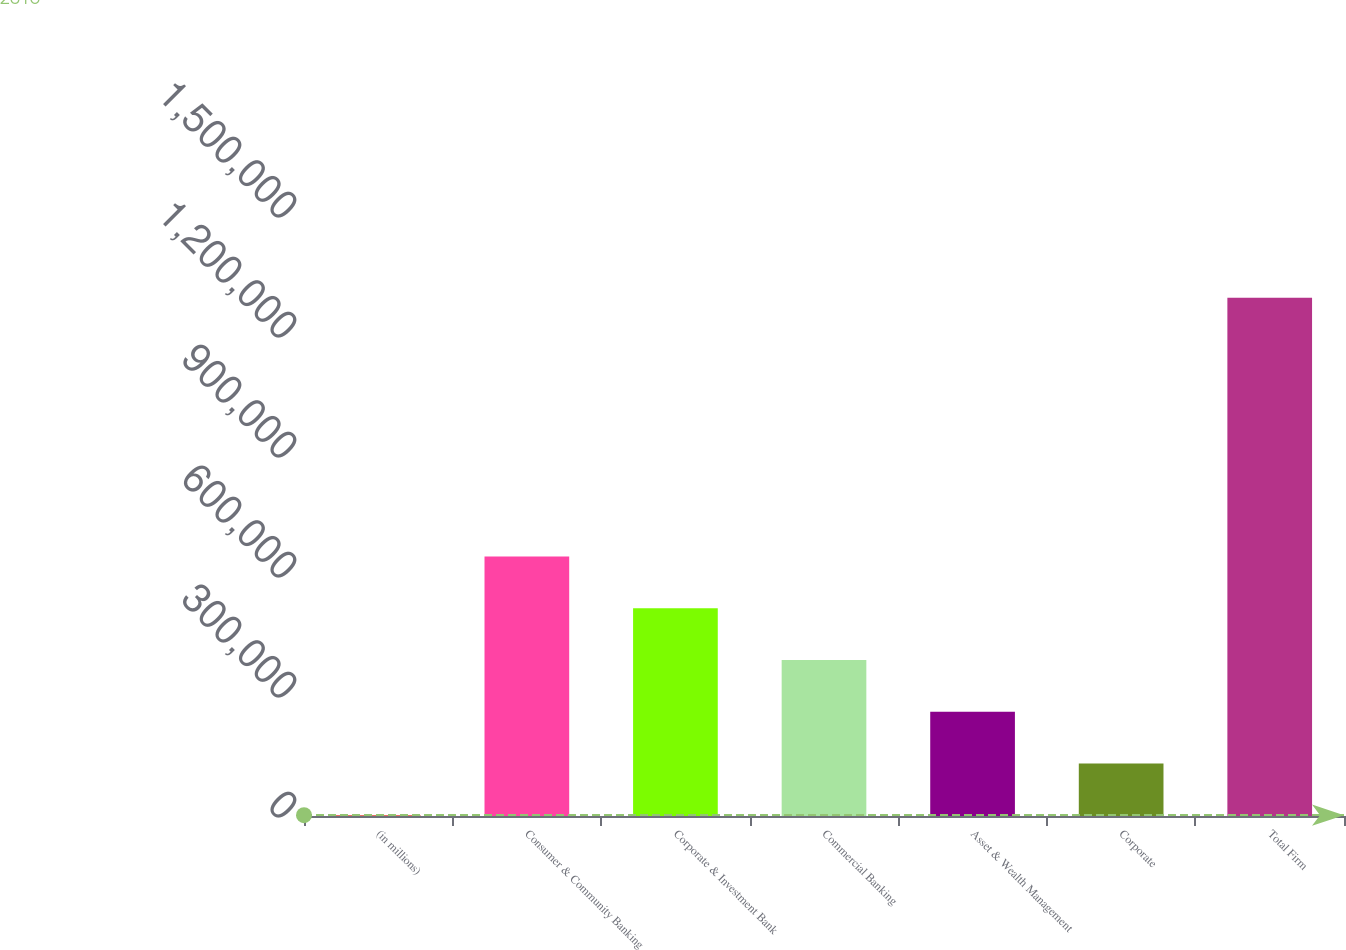Convert chart to OTSL. <chart><loc_0><loc_0><loc_500><loc_500><bar_chart><fcel>(in millions)<fcel>Consumer & Community Banking<fcel>Corporate & Investment Bank<fcel>Commercial Banking<fcel>Asset & Wealth Management<fcel>Corporate<fcel>Total Firm<nl><fcel>2015<fcel>648902<fcel>519524<fcel>390147<fcel>260770<fcel>131392<fcel>1.29579e+06<nl></chart> 